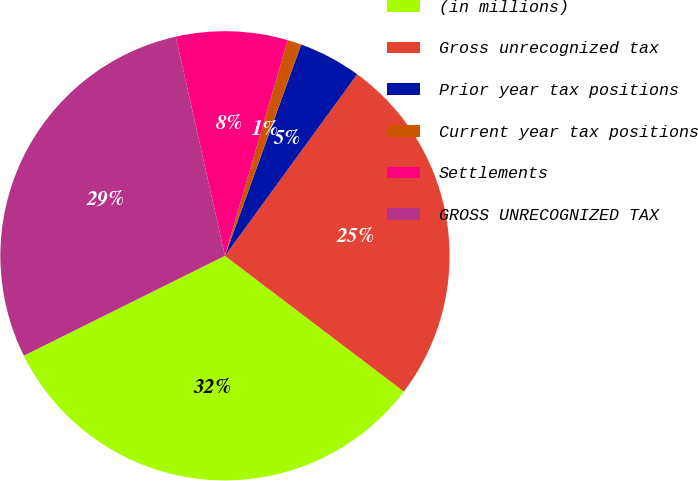Convert chart to OTSL. <chart><loc_0><loc_0><loc_500><loc_500><pie_chart><fcel>(in millions)<fcel>Gross unrecognized tax<fcel>Prior year tax positions<fcel>Current year tax positions<fcel>Settlements<fcel>GROSS UNRECOGNIZED TAX<nl><fcel>32.33%<fcel>25.31%<fcel>4.51%<fcel>1.0%<fcel>8.02%<fcel>28.82%<nl></chart> 